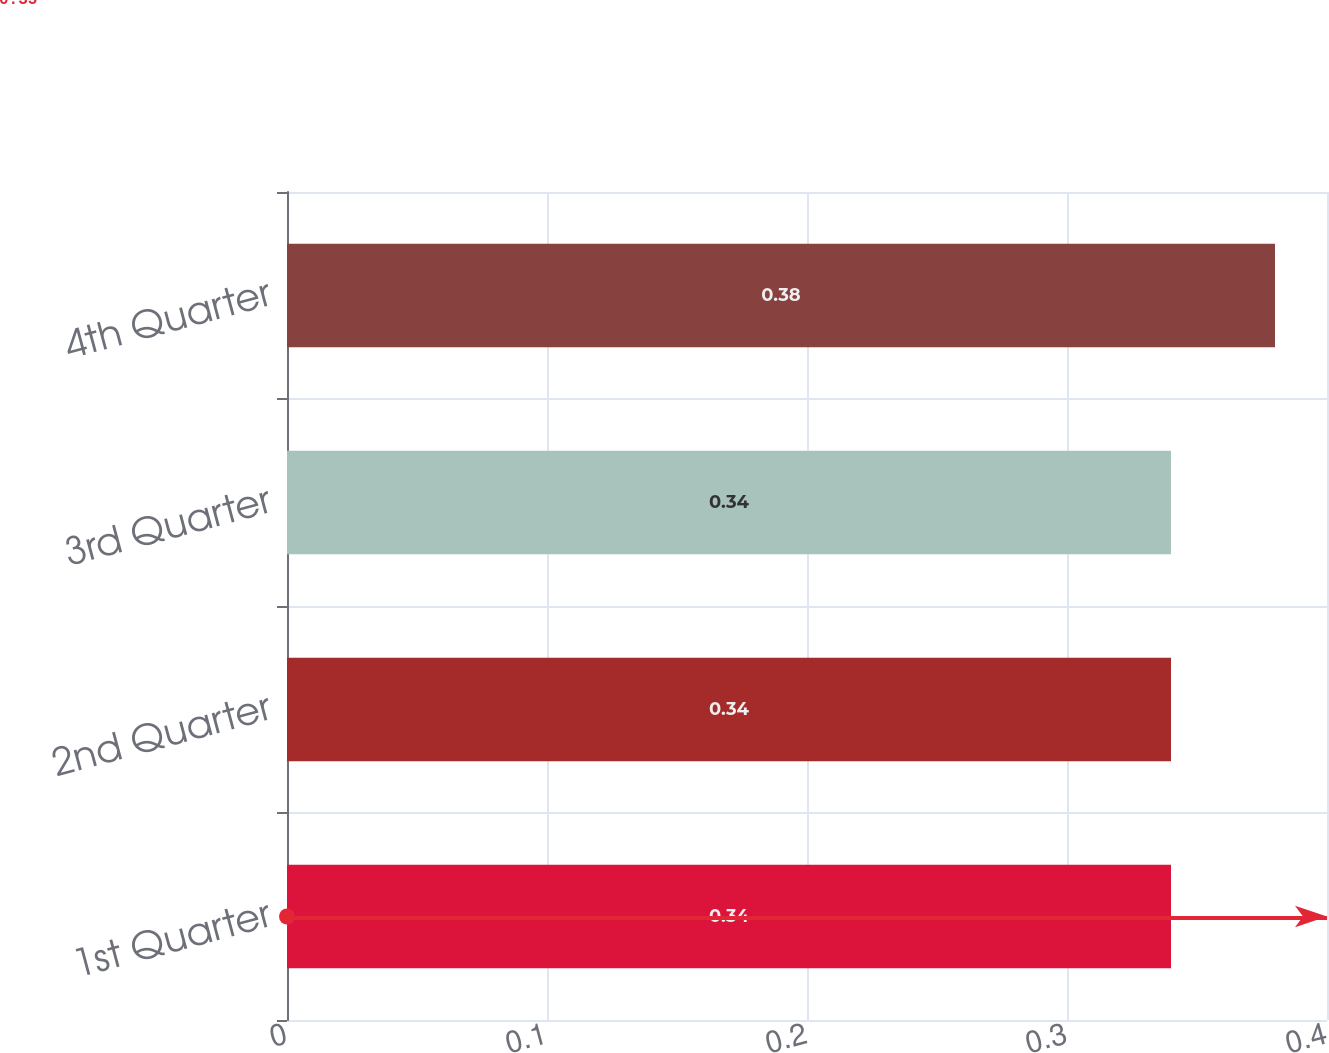<chart> <loc_0><loc_0><loc_500><loc_500><bar_chart><fcel>1st Quarter<fcel>2nd Quarter<fcel>3rd Quarter<fcel>4th Quarter<nl><fcel>0.34<fcel>0.34<fcel>0.34<fcel>0.38<nl></chart> 